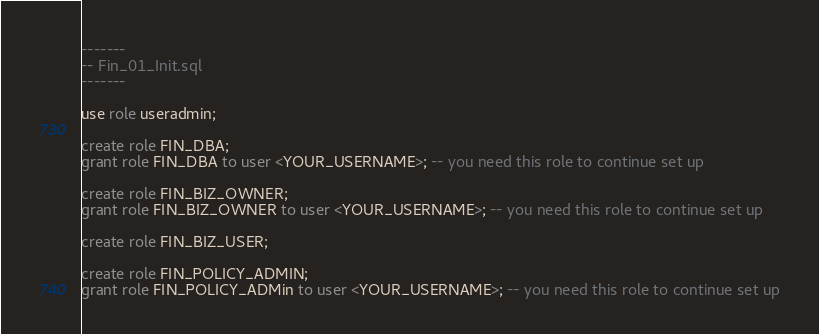<code> <loc_0><loc_0><loc_500><loc_500><_SQL_>-------
-- Fin_01_Init.sql
-------

use role useradmin;

create role FIN_DBA;
grant role FIN_DBA to user <YOUR_USERNAME>; -- you need this role to continue set up

create role FIN_BIZ_OWNER;
grant role FIN_BIZ_OWNER to user <YOUR_USERNAME>; -- you need this role to continue set up

create role FIN_BIZ_USER;

create role FIN_POLICY_ADMIN;
grant role FIN_POLICY_ADMin to user <YOUR_USERNAME>; -- you need this role to continue set up
</code> 